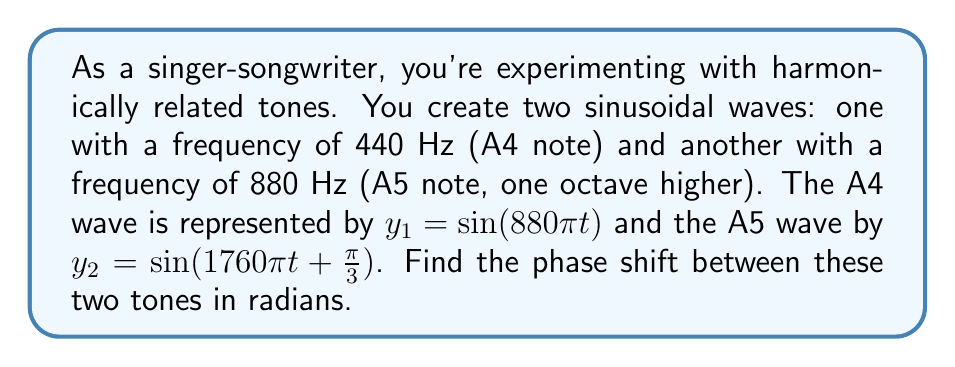Can you answer this question? To find the phase shift between two harmonically related tones, we need to compare their phase angles. Let's approach this step-by-step:

1) The general form of a sinusoidal function is:
   $y = A\sin(Bt + C)$
   where $B$ is the angular frequency and $C$ is the phase angle.

2) For $y_1 = \sin(880\pi t)$:
   $B_1 = 880\pi$ and $C_1 = 0$

3) For $y_2 = \sin(1760\pi t + \frac{\pi}{3})$:
   $B_2 = 1760\pi$ and $C_2 = \frac{\pi}{3}$

4) The phase shift is the difference between these phase angles:
   Phase shift = $C_2 - C_1 = \frac{\pi}{3} - 0 = \frac{\pi}{3}$

5) Note that the difference in angular frequencies doesn't affect the phase shift, as we're concerned with the starting position of the waves, not their speeds.

Therefore, the phase shift between the two tones is $\frac{\pi}{3}$ radians.
Answer: $\frac{\pi}{3}$ radians 